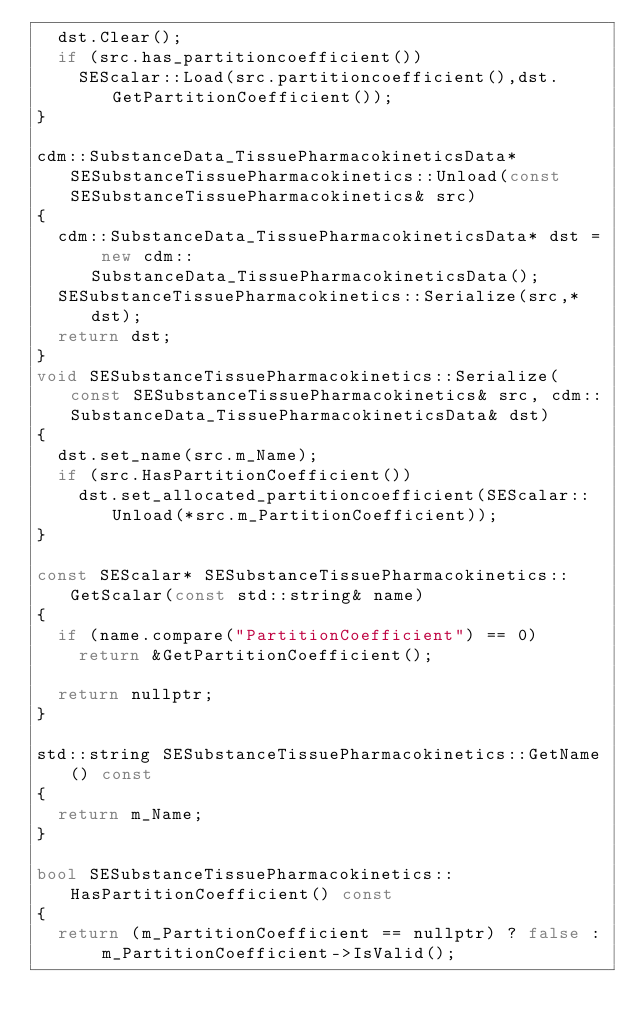Convert code to text. <code><loc_0><loc_0><loc_500><loc_500><_C++_>  dst.Clear();
  if (src.has_partitioncoefficient())
    SEScalar::Load(src.partitioncoefficient(),dst.GetPartitionCoefficient());
}

cdm::SubstanceData_TissuePharmacokineticsData* SESubstanceTissuePharmacokinetics::Unload(const SESubstanceTissuePharmacokinetics& src)
{
  cdm::SubstanceData_TissuePharmacokineticsData* dst = new cdm::SubstanceData_TissuePharmacokineticsData();
  SESubstanceTissuePharmacokinetics::Serialize(src,*dst);
  return dst;
}
void SESubstanceTissuePharmacokinetics::Serialize(const SESubstanceTissuePharmacokinetics& src, cdm::SubstanceData_TissuePharmacokineticsData& dst)
{
  dst.set_name(src.m_Name);
  if (src.HasPartitionCoefficient())
    dst.set_allocated_partitioncoefficient(SEScalar::Unload(*src.m_PartitionCoefficient));
}

const SEScalar* SESubstanceTissuePharmacokinetics::GetScalar(const std::string& name)
{
  if (name.compare("PartitionCoefficient") == 0)
    return &GetPartitionCoefficient();

  return nullptr;
}

std::string SESubstanceTissuePharmacokinetics::GetName() const
{
  return m_Name;
}

bool SESubstanceTissuePharmacokinetics::HasPartitionCoefficient() const
{
  return (m_PartitionCoefficient == nullptr) ? false : m_PartitionCoefficient->IsValid();</code> 